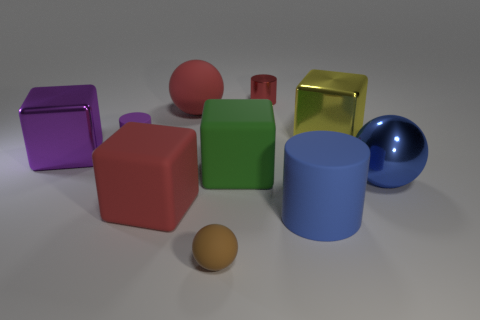Subtract all cylinders. How many objects are left? 7 Add 3 purple matte things. How many purple matte things are left? 4 Add 7 matte blocks. How many matte blocks exist? 9 Subtract 1 red cubes. How many objects are left? 9 Subtract all tiny red cylinders. Subtract all large red matte cubes. How many objects are left? 8 